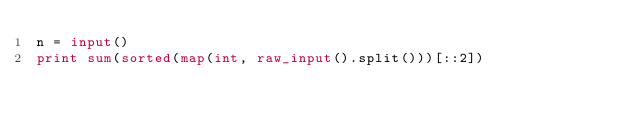Convert code to text. <code><loc_0><loc_0><loc_500><loc_500><_Python_>n = input()
print sum(sorted(map(int, raw_input().split()))[::2])</code> 